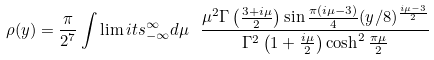Convert formula to latex. <formula><loc_0><loc_0><loc_500><loc_500>\rho ( y ) = \frac { \pi } { 2 ^ { 7 } } \int \lim i t s _ { - \infty } ^ { \infty } d \mu \ \frac { \mu ^ { 2 } \Gamma \left ( \frac { 3 + i \mu } { 2 } \right ) \sin { \frac { \pi ( i \mu - 3 ) } { 4 } } ( y / 8 ) ^ { \frac { i \mu - 3 } { 2 } } } { \Gamma ^ { 2 } \left ( 1 + \frac { i \mu } { 2 } \right ) \cosh ^ { 2 } \frac { \pi \mu } { 2 } }</formula> 